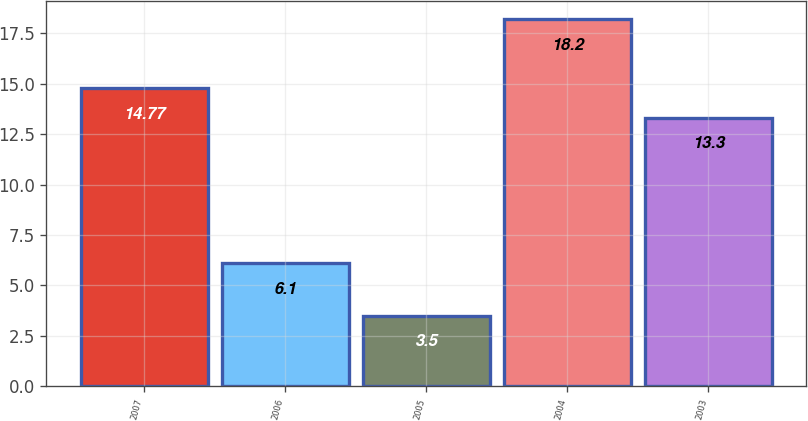Convert chart to OTSL. <chart><loc_0><loc_0><loc_500><loc_500><bar_chart><fcel>2007<fcel>2006<fcel>2005<fcel>2004<fcel>2003<nl><fcel>14.77<fcel>6.1<fcel>3.5<fcel>18.2<fcel>13.3<nl></chart> 